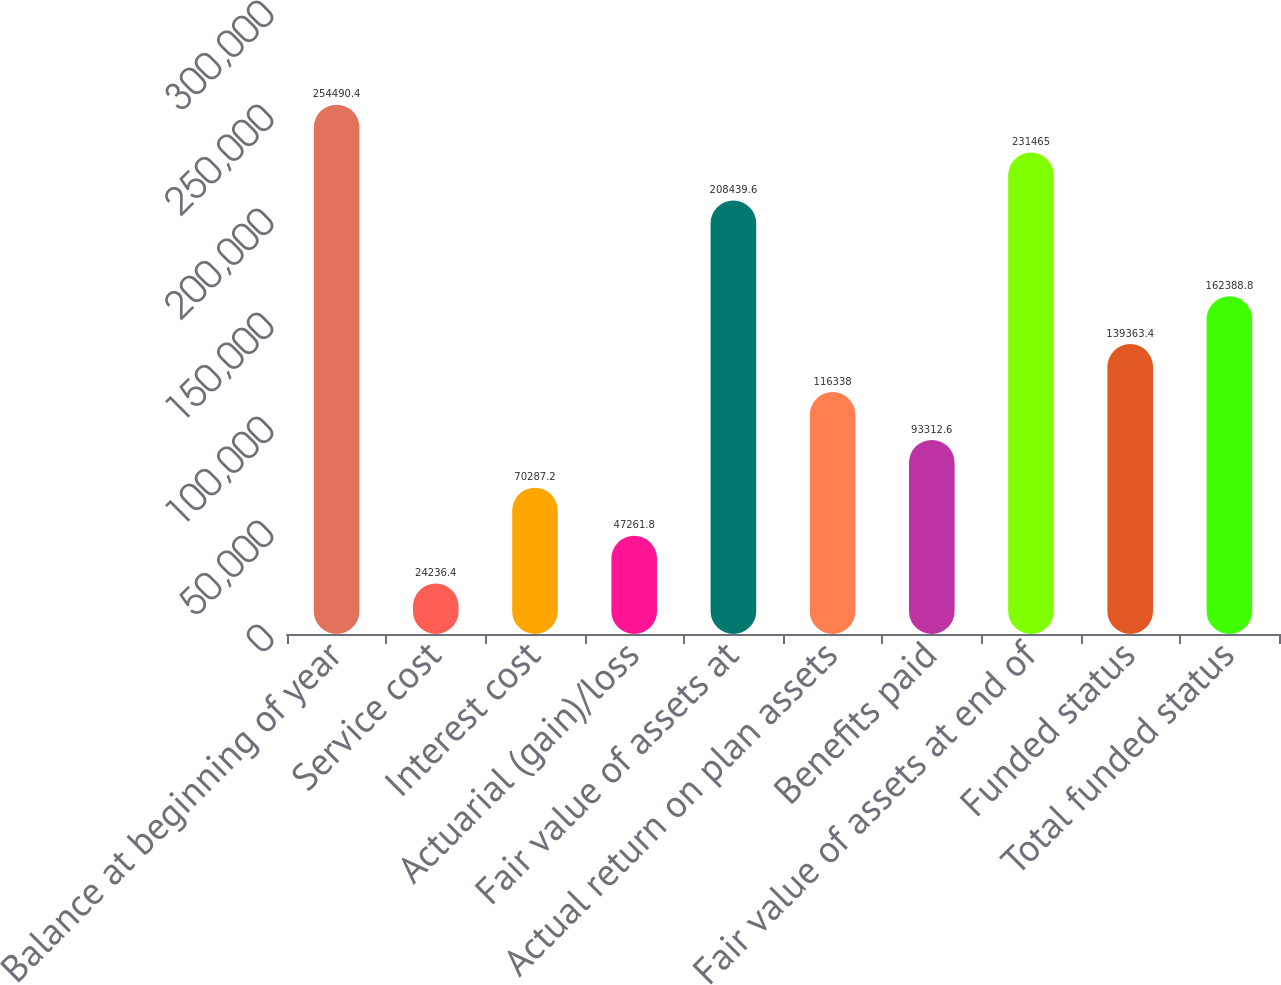Convert chart to OTSL. <chart><loc_0><loc_0><loc_500><loc_500><bar_chart><fcel>Balance at beginning of year<fcel>Service cost<fcel>Interest cost<fcel>Actuarial (gain)/loss<fcel>Fair value of assets at<fcel>Actual return on plan assets<fcel>Benefits paid<fcel>Fair value of assets at end of<fcel>Funded status<fcel>Total funded status<nl><fcel>254490<fcel>24236.4<fcel>70287.2<fcel>47261.8<fcel>208440<fcel>116338<fcel>93312.6<fcel>231465<fcel>139363<fcel>162389<nl></chart> 